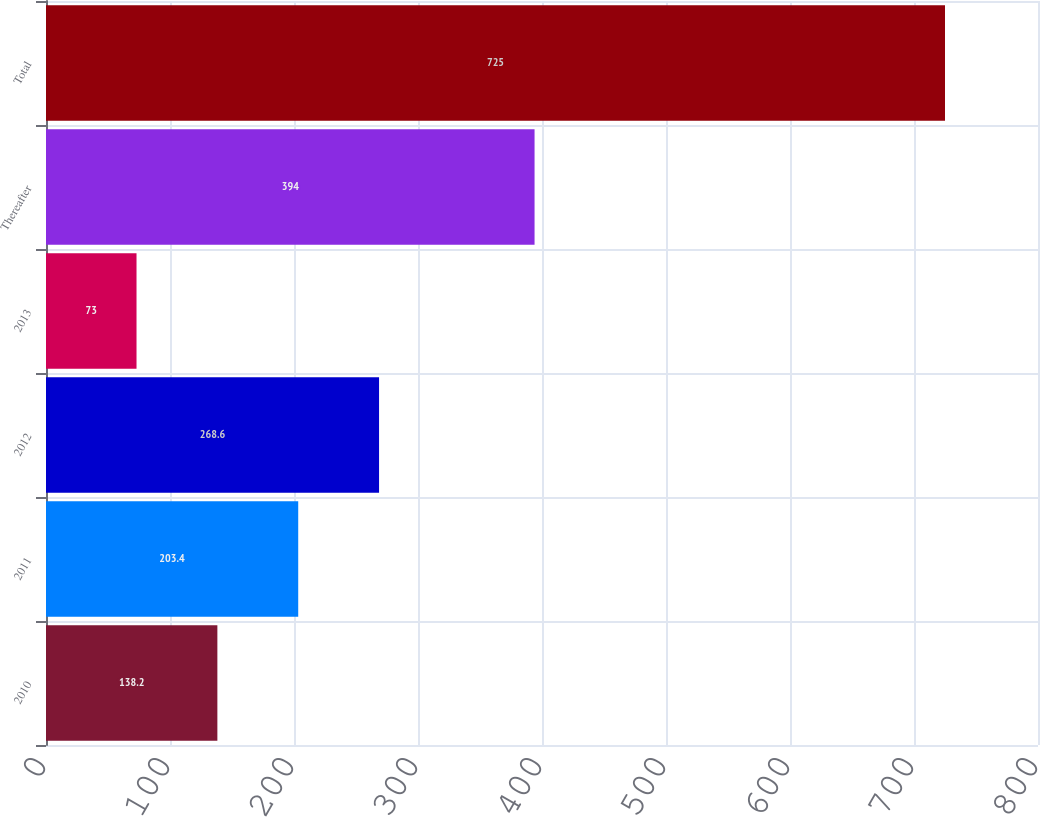Convert chart. <chart><loc_0><loc_0><loc_500><loc_500><bar_chart><fcel>2010<fcel>2011<fcel>2012<fcel>2013<fcel>Thereafter<fcel>Total<nl><fcel>138.2<fcel>203.4<fcel>268.6<fcel>73<fcel>394<fcel>725<nl></chart> 